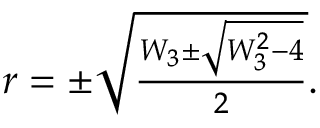<formula> <loc_0><loc_0><loc_500><loc_500>\begin{array} { r } { r = \pm \sqrt { \frac { W _ { 3 } \pm \sqrt { W _ { 3 } ^ { 2 } - 4 } } { 2 } } . } \end{array}</formula> 